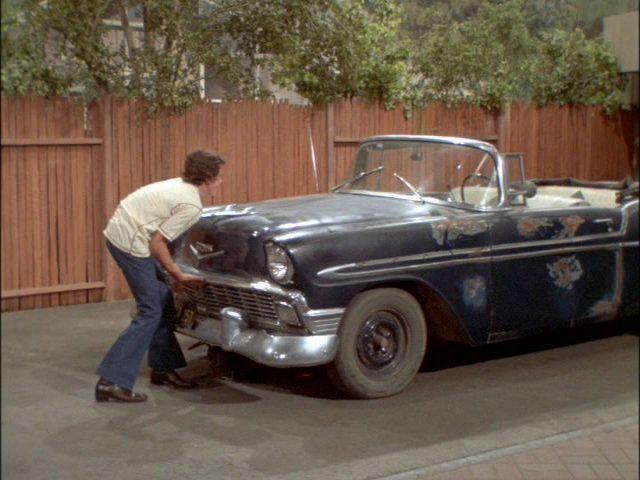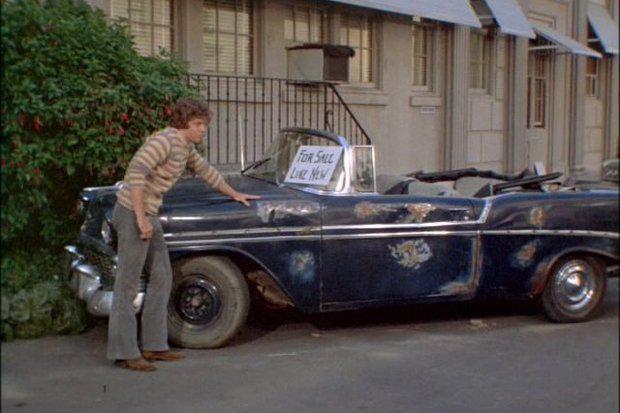The first image is the image on the left, the second image is the image on the right. Considering the images on both sides, is "No one is sitting in the car in the image on the left." valid? Answer yes or no. Yes. The first image is the image on the left, the second image is the image on the right. Analyze the images presented: Is the assertion "An image shows a man sitting behind the wheel of a light blue convertible in front of an open garage." valid? Answer yes or no. No. 